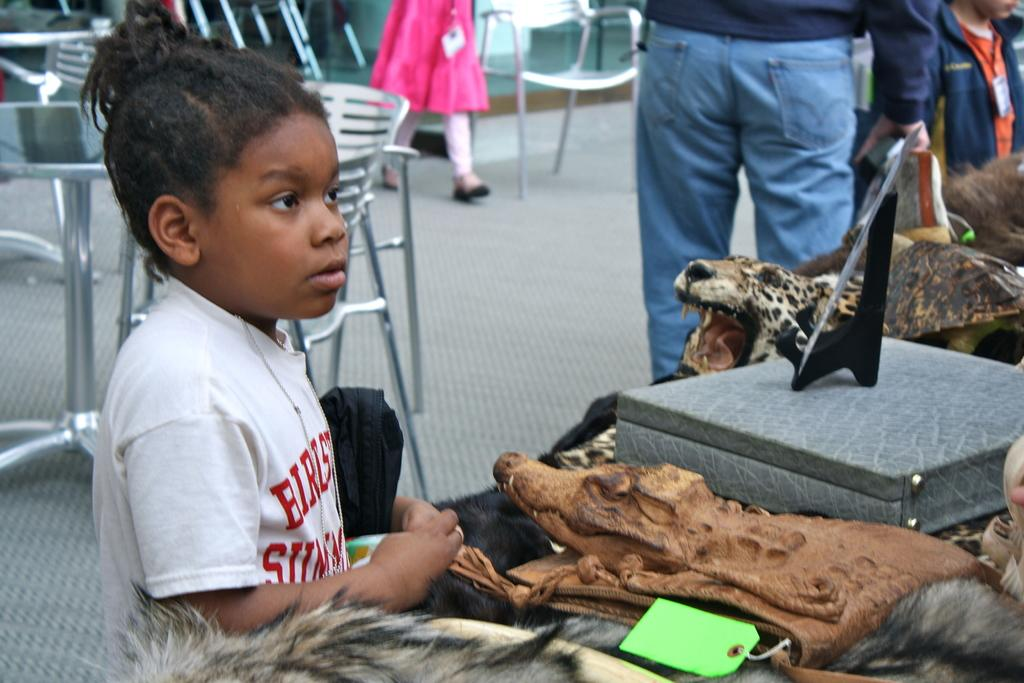What is the main subject of the image? There is a child in the image. What other living beings are present in the image? There are animals in the image. Can you describe any additional objects in the image? There is a tag and a box in the image. What is the setting of the image? There are people standing on the floor, and there are chairs and tables in the background of the image. Is there any movement happening in the background? Yes, there is a person walking in the background of the image. What type of metal can be seen in the bucket in the image? There is no bucket present in the image, so it is not possible to determine the type of metal. 